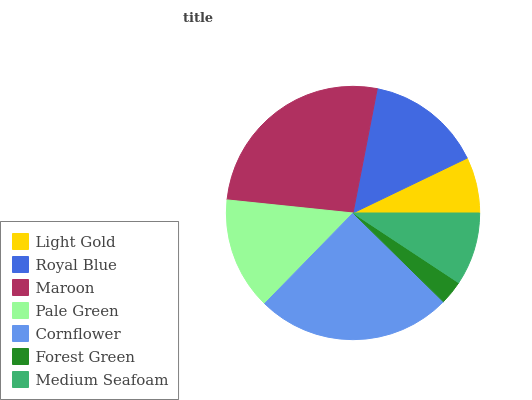Is Forest Green the minimum?
Answer yes or no. Yes. Is Maroon the maximum?
Answer yes or no. Yes. Is Royal Blue the minimum?
Answer yes or no. No. Is Royal Blue the maximum?
Answer yes or no. No. Is Royal Blue greater than Light Gold?
Answer yes or no. Yes. Is Light Gold less than Royal Blue?
Answer yes or no. Yes. Is Light Gold greater than Royal Blue?
Answer yes or no. No. Is Royal Blue less than Light Gold?
Answer yes or no. No. Is Pale Green the high median?
Answer yes or no. Yes. Is Pale Green the low median?
Answer yes or no. Yes. Is Maroon the high median?
Answer yes or no. No. Is Forest Green the low median?
Answer yes or no. No. 